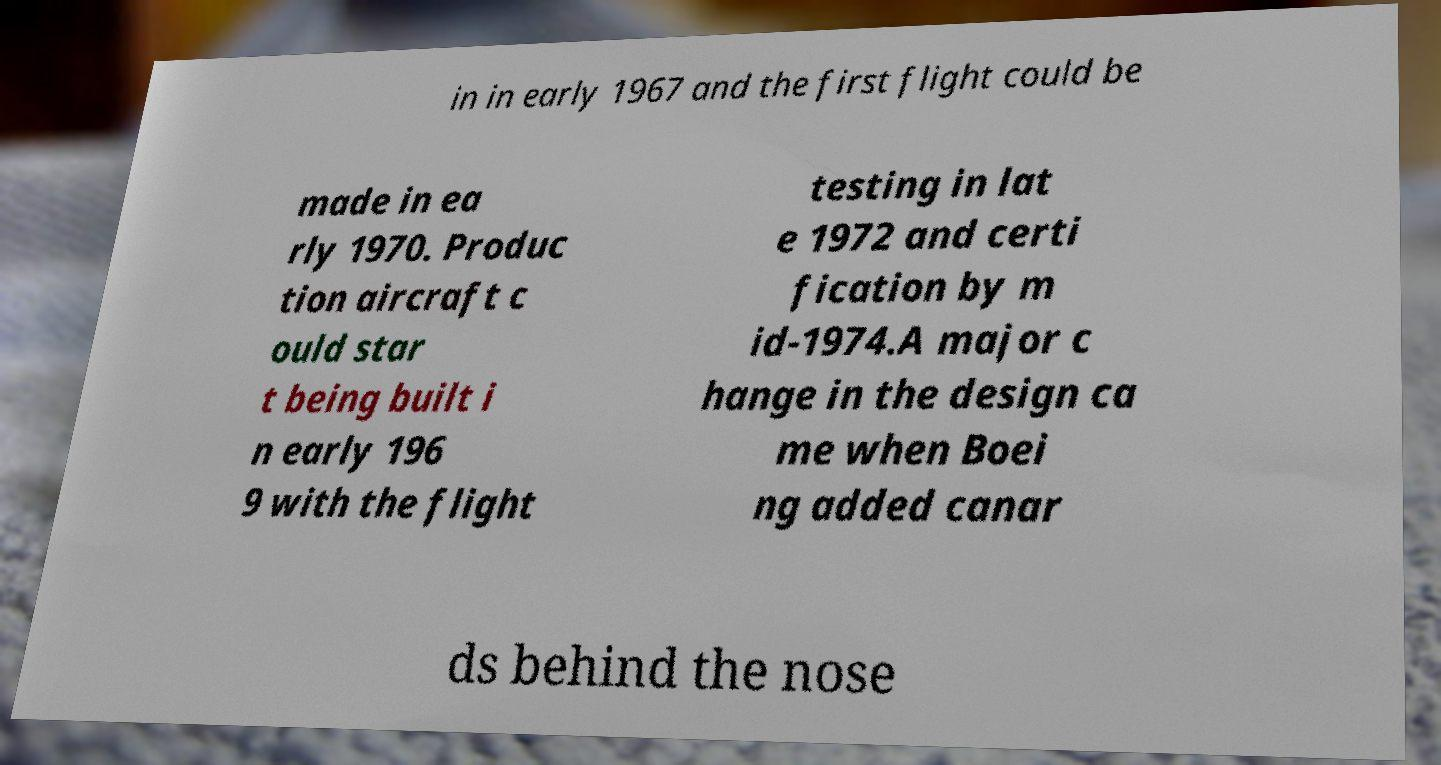There's text embedded in this image that I need extracted. Can you transcribe it verbatim? in in early 1967 and the first flight could be made in ea rly 1970. Produc tion aircraft c ould star t being built i n early 196 9 with the flight testing in lat e 1972 and certi fication by m id-1974.A major c hange in the design ca me when Boei ng added canar ds behind the nose 